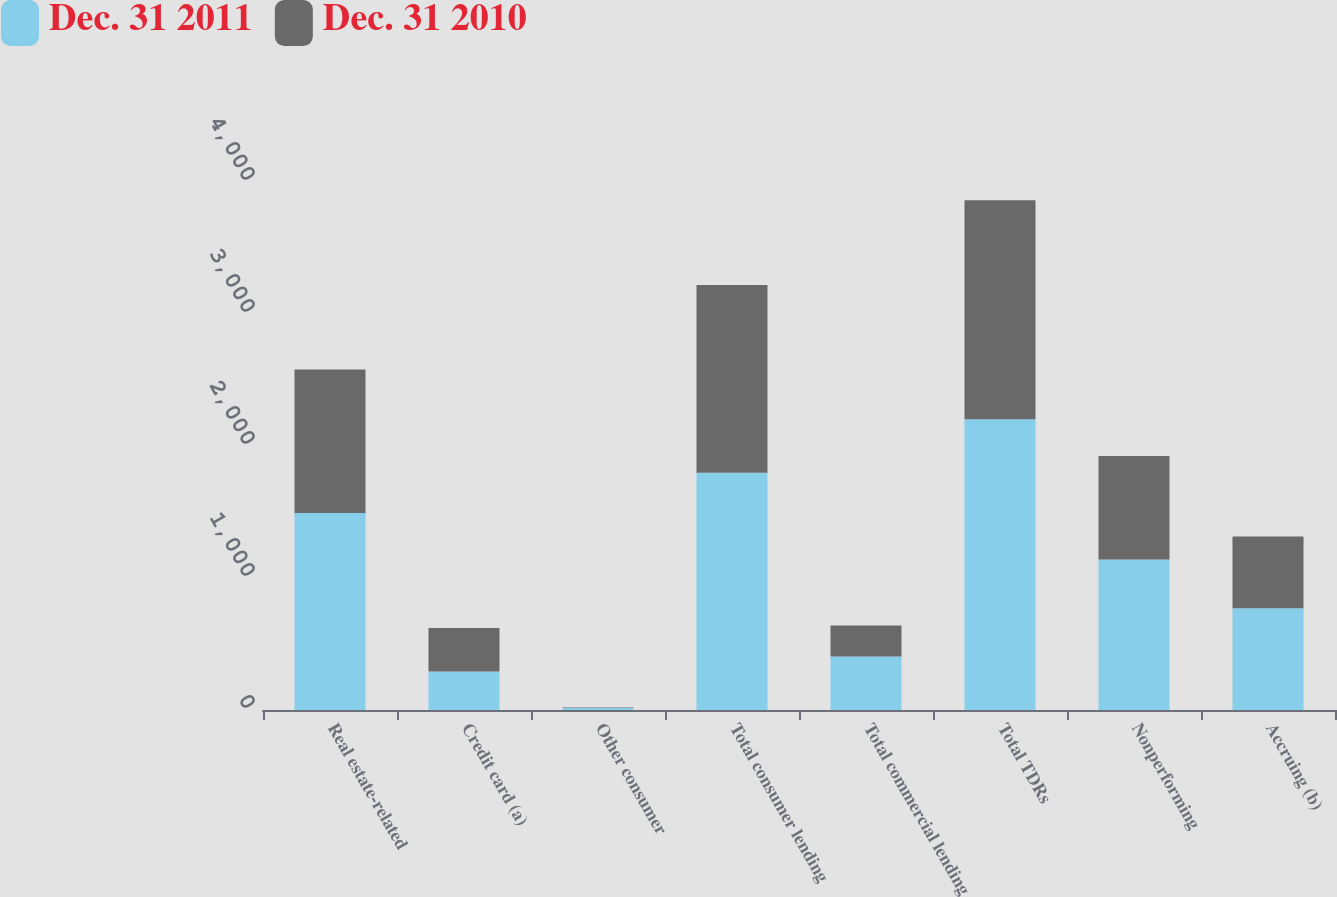<chart> <loc_0><loc_0><loc_500><loc_500><stacked_bar_chart><ecel><fcel>Real estate-related<fcel>Credit card (a)<fcel>Other consumer<fcel>Total consumer lending<fcel>Total commercial lending<fcel>Total TDRs<fcel>Nonperforming<fcel>Accruing (b)<nl><fcel>Dec. 31 2011<fcel>1492<fcel>291<fcel>15<fcel>1798<fcel>405<fcel>2203<fcel>1141<fcel>771<nl><fcel>Dec. 31 2010<fcel>1087<fcel>331<fcel>4<fcel>1422<fcel>236<fcel>1658<fcel>784<fcel>543<nl></chart> 